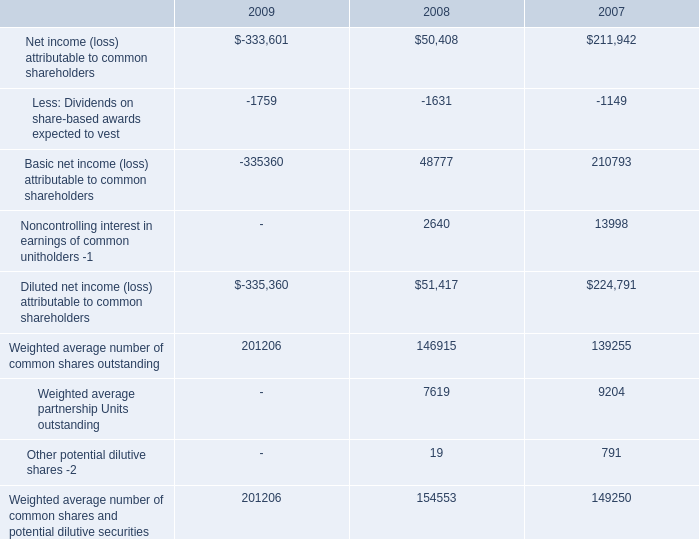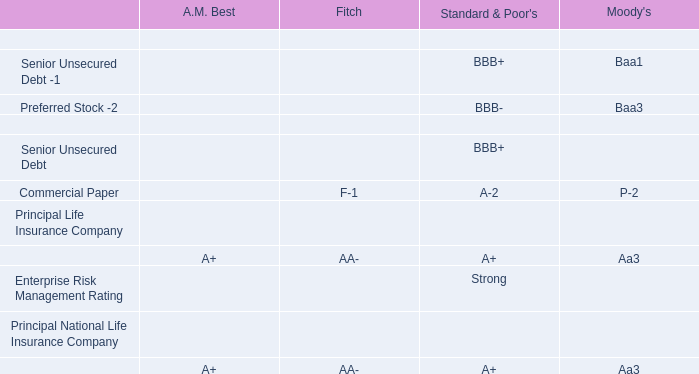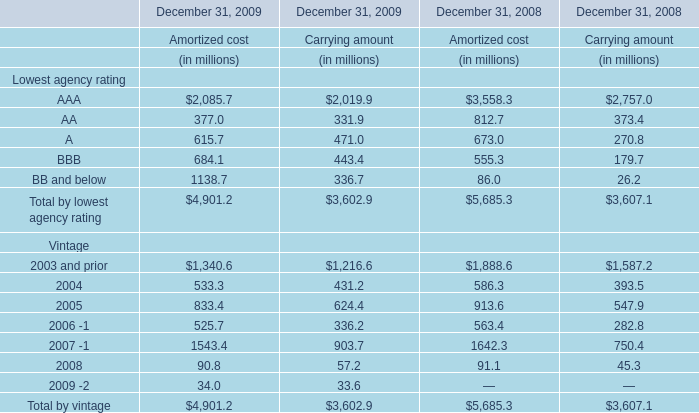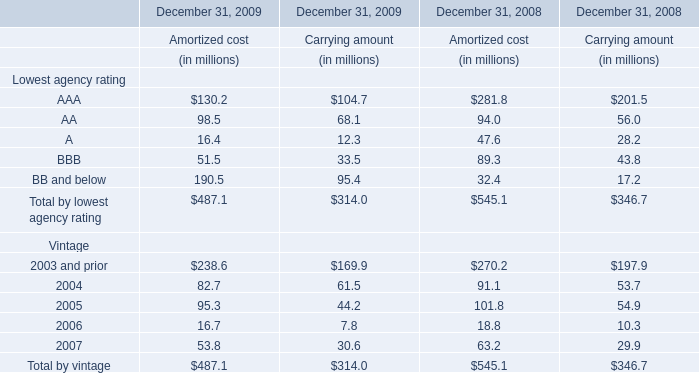What was the total amount of elements for Amortized cost in the range of 100 and 200 in 2009? (in million) 
Computations: (130.2 + 190.5)
Answer: 320.7. 